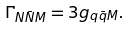<formula> <loc_0><loc_0><loc_500><loc_500>\Gamma _ { N \bar { N } M } = 3 g _ { q \bar { q } M } .</formula> 